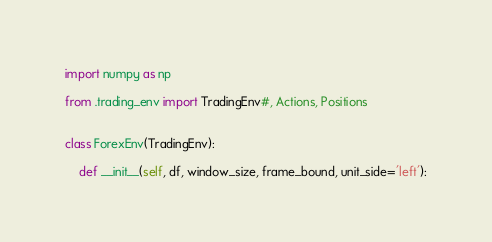Convert code to text. <code><loc_0><loc_0><loc_500><loc_500><_Python_>import numpy as np

from .trading_env import TradingEnv#, Actions, Positions


class ForexEnv(TradingEnv):

    def __init__(self, df, window_size, frame_bound, unit_side='left'):</code> 